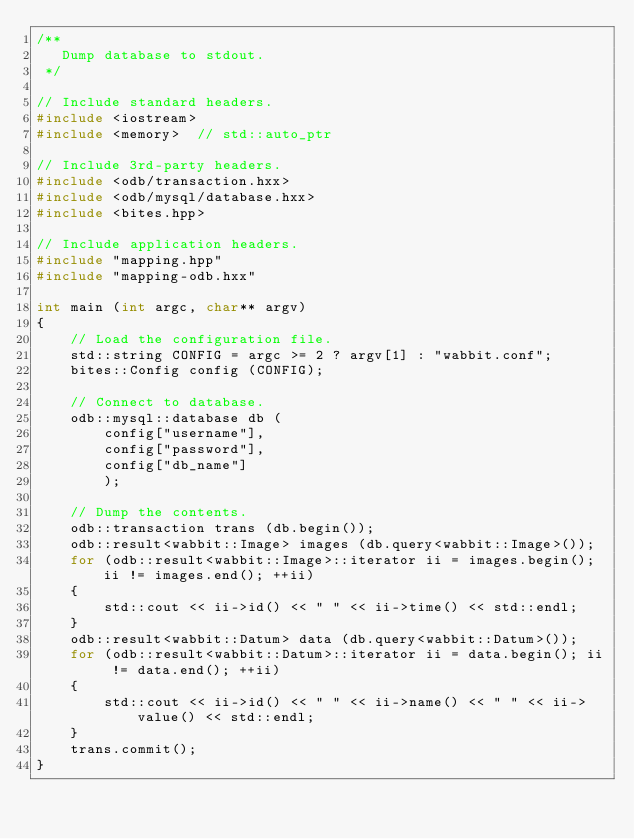<code> <loc_0><loc_0><loc_500><loc_500><_C++_>/**
   Dump database to stdout.
 */

// Include standard headers.
#include <iostream>
#include <memory>  // std::auto_ptr

// Include 3rd-party headers.
#include <odb/transaction.hxx>
#include <odb/mysql/database.hxx>
#include <bites.hpp>

// Include application headers.
#include "mapping.hpp"
#include "mapping-odb.hxx"

int main (int argc, char** argv)
{
    // Load the configuration file.
    std::string CONFIG = argc >= 2 ? argv[1] : "wabbit.conf";
    bites::Config config (CONFIG);

    // Connect to database.    
    odb::mysql::database db (
        config["username"],
        config["password"],
        config["db_name"]
        );

    // Dump the contents.
    odb::transaction trans (db.begin());
    odb::result<wabbit::Image> images (db.query<wabbit::Image>());
    for (odb::result<wabbit::Image>::iterator ii = images.begin(); ii != images.end(); ++ii)
    {
        std::cout << ii->id() << " " << ii->time() << std::endl;
    }
    odb::result<wabbit::Datum> data (db.query<wabbit::Datum>());
    for (odb::result<wabbit::Datum>::iterator ii = data.begin(); ii != data.end(); ++ii)
    {
        std::cout << ii->id() << " " << ii->name() << " " << ii->value() << std::endl;
    }
    trans.commit();
}
</code> 